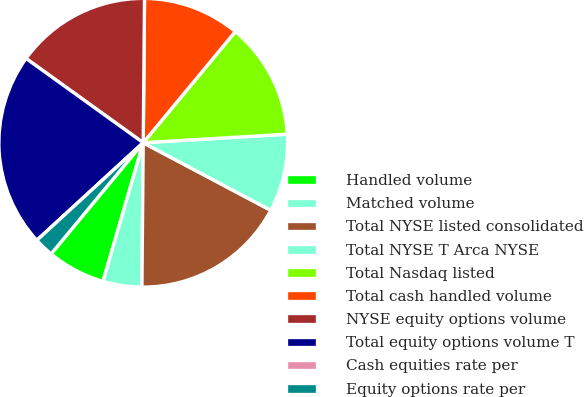<chart> <loc_0><loc_0><loc_500><loc_500><pie_chart><fcel>Handled volume<fcel>Matched volume<fcel>Total NYSE listed consolidated<fcel>Total NYSE T Arca NYSE<fcel>Total Nasdaq listed<fcel>Total cash handled volume<fcel>NYSE equity options volume<fcel>Total equity options volume T<fcel>Cash equities rate per<fcel>Equity options rate per<nl><fcel>6.52%<fcel>4.35%<fcel>17.39%<fcel>8.7%<fcel>13.04%<fcel>10.87%<fcel>15.22%<fcel>21.74%<fcel>0.0%<fcel>2.17%<nl></chart> 